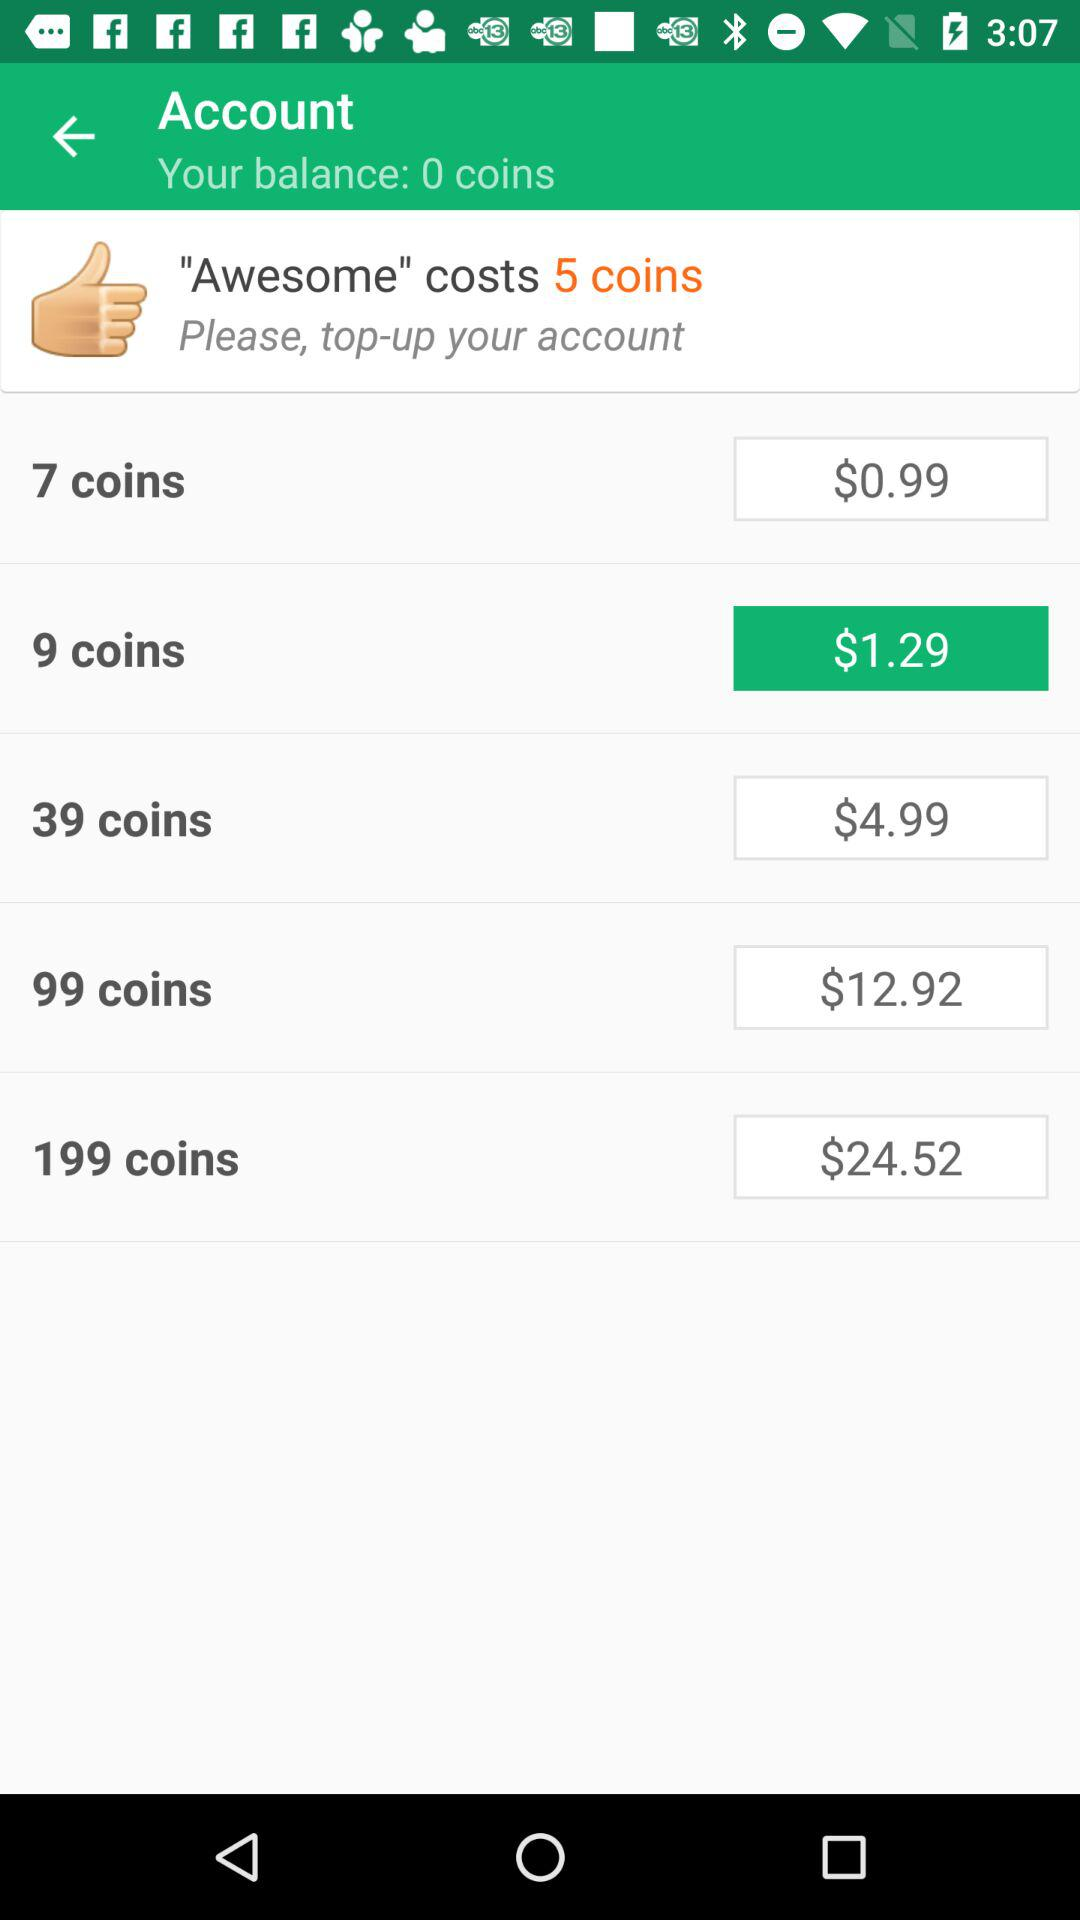How much is the cost of 9 coins? The cost of 9 coins is $1.29. 